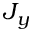Convert formula to latex. <formula><loc_0><loc_0><loc_500><loc_500>J _ { y }</formula> 